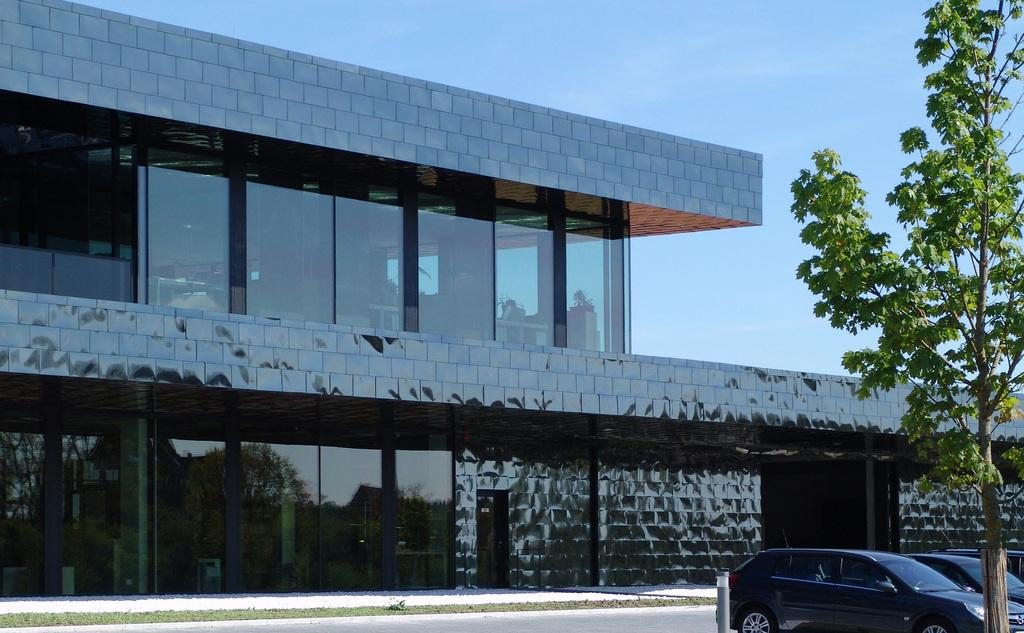What type of structure is visible in the image? There is a building in the image. What is unique about the building's walls? The building has glass walls. What type of vehicles can be seen in the image? There are cars in the image. What type of plant is present in the image? There is a tree in the image. What is the condition of the sky in the image? The sky is clear in the image. Where is the oven located in the image? There is no oven present in the image. What type of badge is being worn by the tree in the image? There are no badges present in the image, as it features a building, cars, a tree, and a clear sky. 